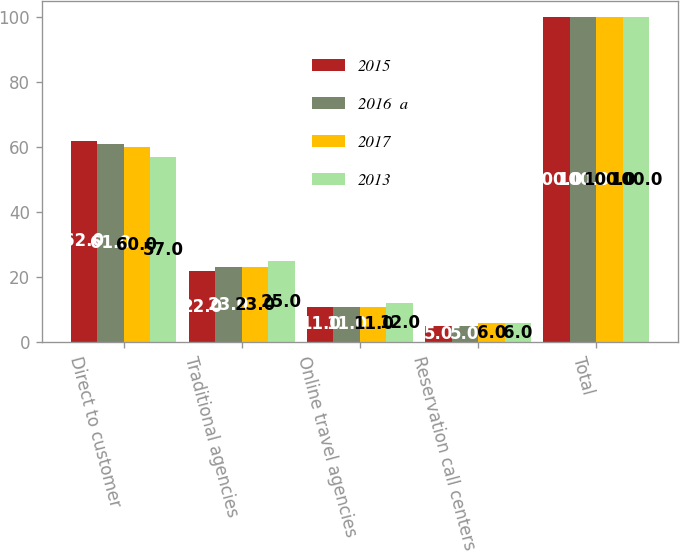Convert chart. <chart><loc_0><loc_0><loc_500><loc_500><stacked_bar_chart><ecel><fcel>Direct to customer<fcel>Traditional agencies<fcel>Online travel agencies<fcel>Reservation call centers<fcel>Total<nl><fcel>2015<fcel>62<fcel>22<fcel>11<fcel>5<fcel>100<nl><fcel>2016  a<fcel>61<fcel>23<fcel>11<fcel>5<fcel>100<nl><fcel>2017<fcel>60<fcel>23<fcel>11<fcel>6<fcel>100<nl><fcel>2013<fcel>57<fcel>25<fcel>12<fcel>6<fcel>100<nl></chart> 